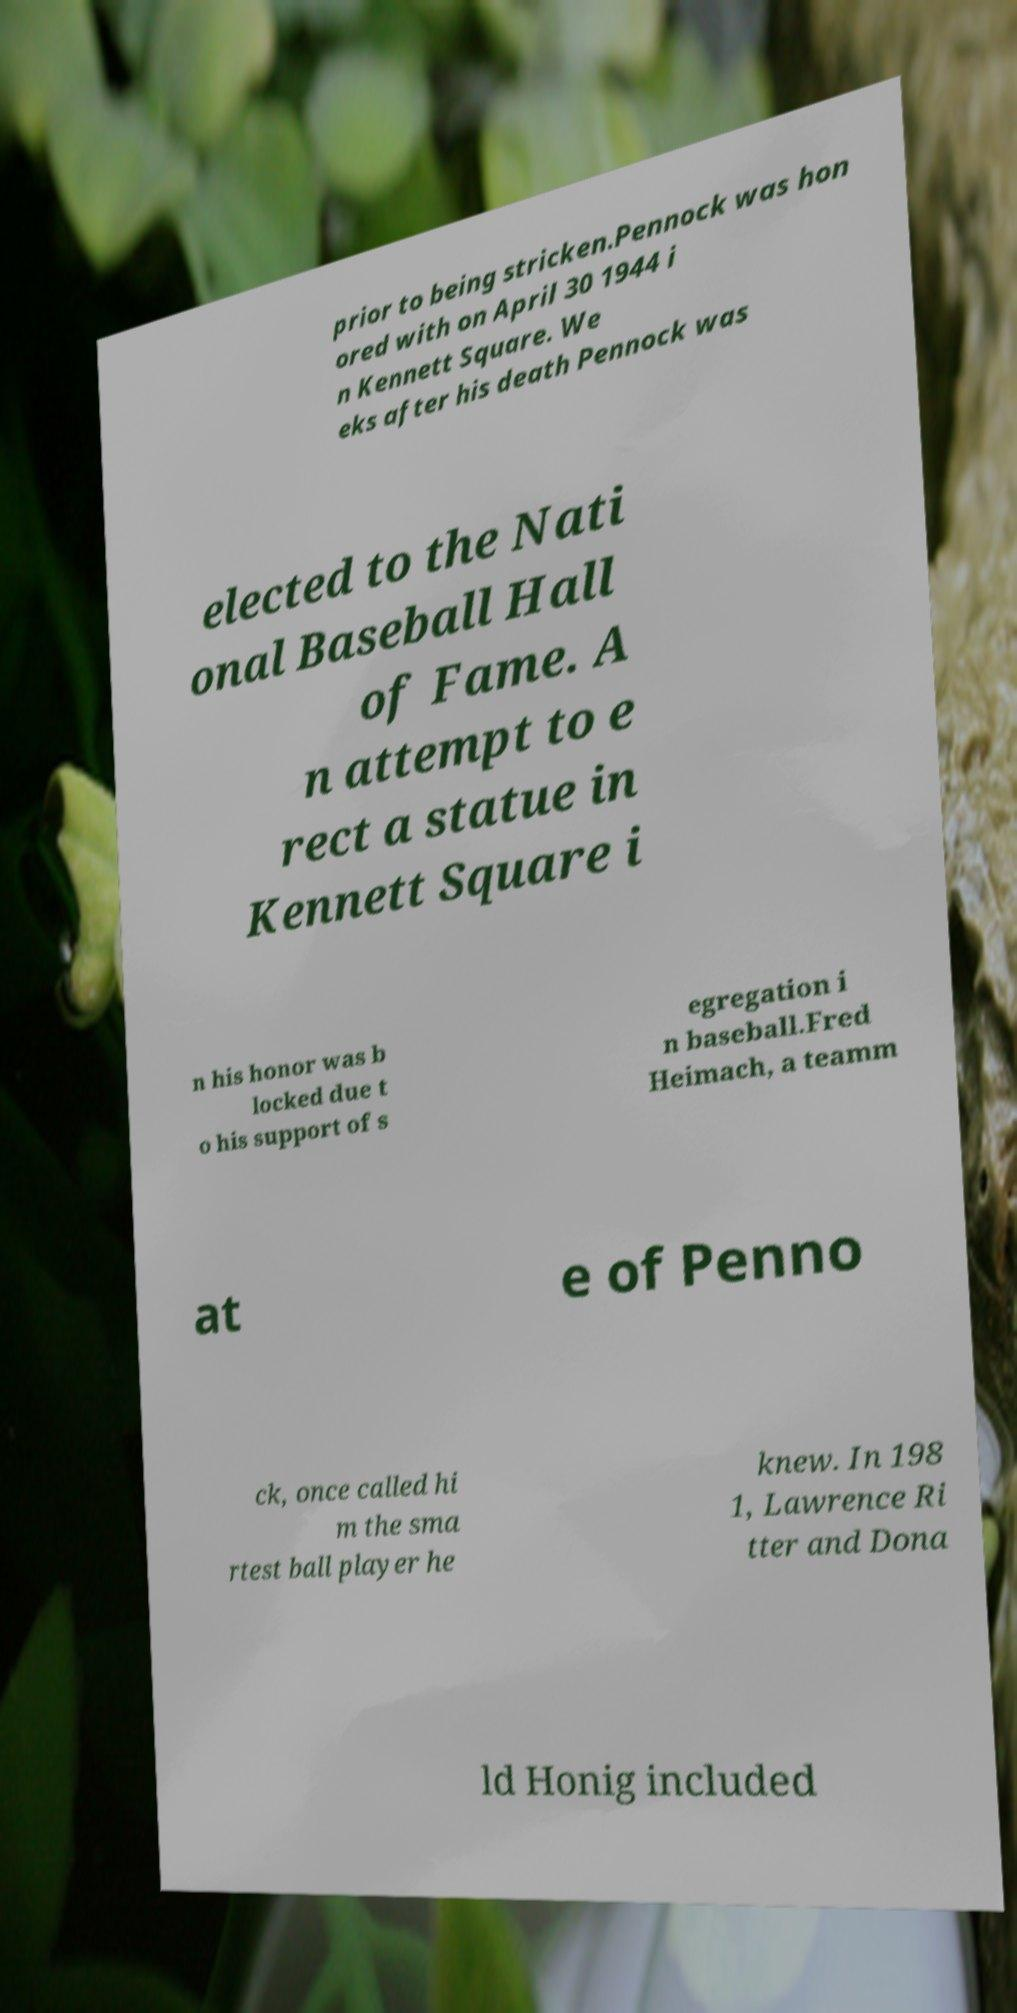Could you assist in decoding the text presented in this image and type it out clearly? prior to being stricken.Pennock was hon ored with on April 30 1944 i n Kennett Square. We eks after his death Pennock was elected to the Nati onal Baseball Hall of Fame. A n attempt to e rect a statue in Kennett Square i n his honor was b locked due t o his support of s egregation i n baseball.Fred Heimach, a teamm at e of Penno ck, once called hi m the sma rtest ball player he knew. In 198 1, Lawrence Ri tter and Dona ld Honig included 